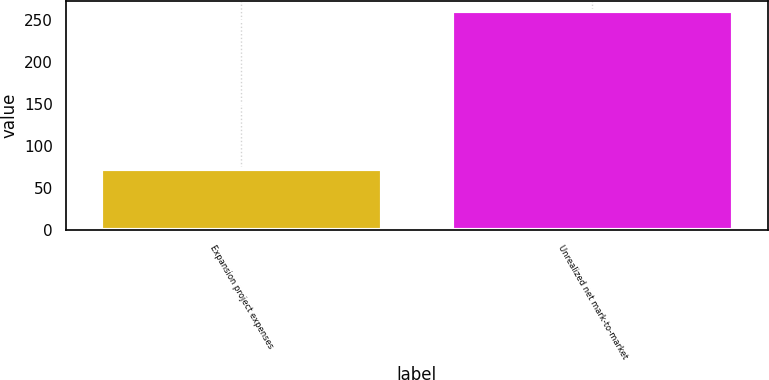Convert chart to OTSL. <chart><loc_0><loc_0><loc_500><loc_500><bar_chart><fcel>Expansion project expenses<fcel>Unrealized net mark-to-market<nl><fcel>73<fcel>260<nl></chart> 